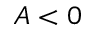Convert formula to latex. <formula><loc_0><loc_0><loc_500><loc_500>A < 0</formula> 